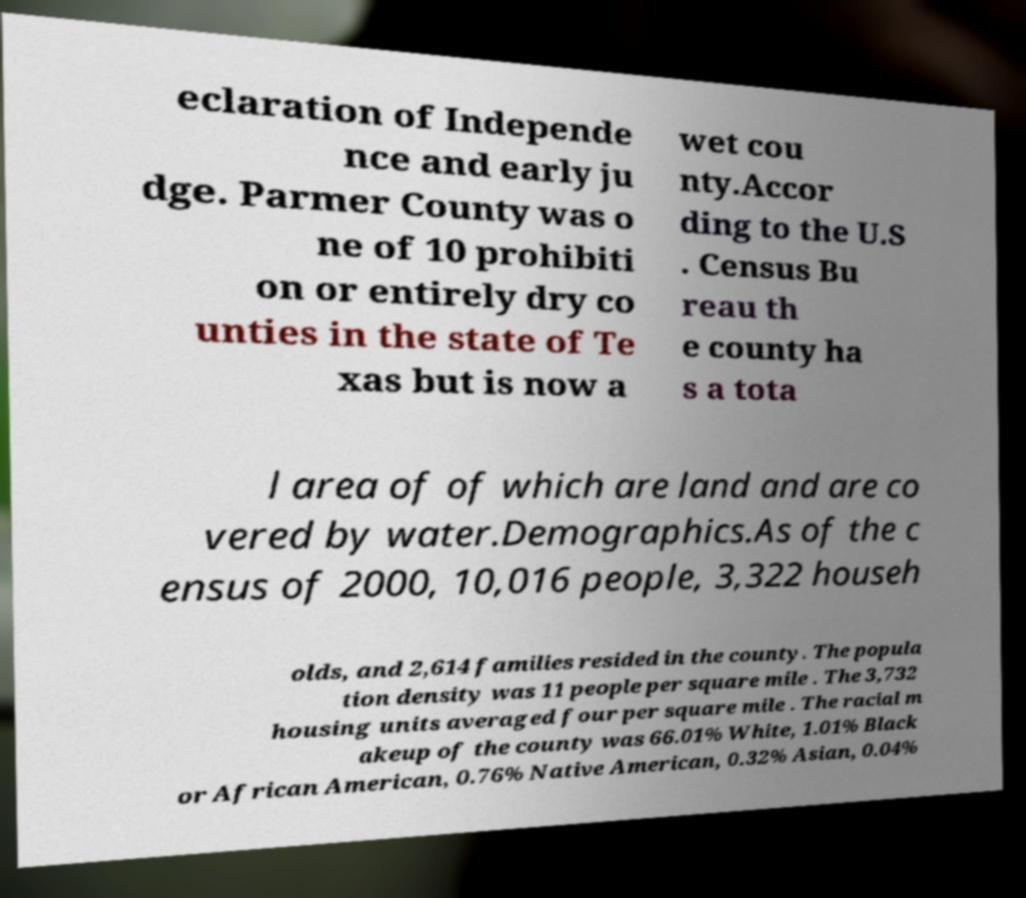Could you assist in decoding the text presented in this image and type it out clearly? eclaration of Independe nce and early ju dge. Parmer County was o ne of 10 prohibiti on or entirely dry co unties in the state of Te xas but is now a wet cou nty.Accor ding to the U.S . Census Bu reau th e county ha s a tota l area of of which are land and are co vered by water.Demographics.As of the c ensus of 2000, 10,016 people, 3,322 househ olds, and 2,614 families resided in the county. The popula tion density was 11 people per square mile . The 3,732 housing units averaged four per square mile . The racial m akeup of the county was 66.01% White, 1.01% Black or African American, 0.76% Native American, 0.32% Asian, 0.04% 